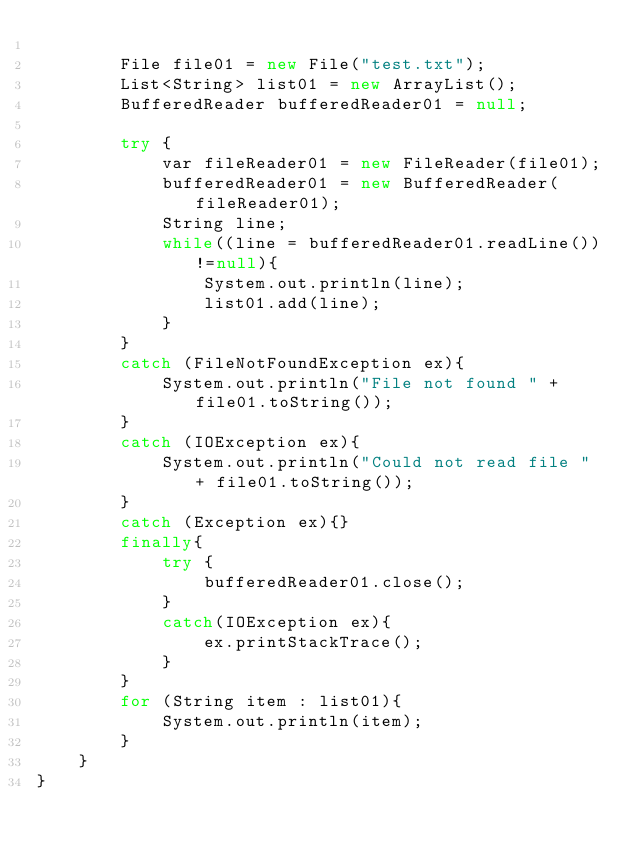Convert code to text. <code><loc_0><loc_0><loc_500><loc_500><_Java_>
        File file01 = new File("test.txt");
        List<String> list01 = new ArrayList();
        BufferedReader bufferedReader01 = null;

        try {
            var fileReader01 = new FileReader(file01);
            bufferedReader01 = new BufferedReader(fileReader01);
            String line;
            while((line = bufferedReader01.readLine())!=null){
                System.out.println(line);
                list01.add(line);
            }
        }
        catch (FileNotFoundException ex){
            System.out.println("File not found " + file01.toString());
        }
        catch (IOException ex){
            System.out.println("Could not read file " + file01.toString());
        }
        catch (Exception ex){}
        finally{
            try {
                bufferedReader01.close();
            }
            catch(IOException ex){
                ex.printStackTrace();
            }
        }
        for (String item : list01){
            System.out.println(item);
        }
    }
}
</code> 